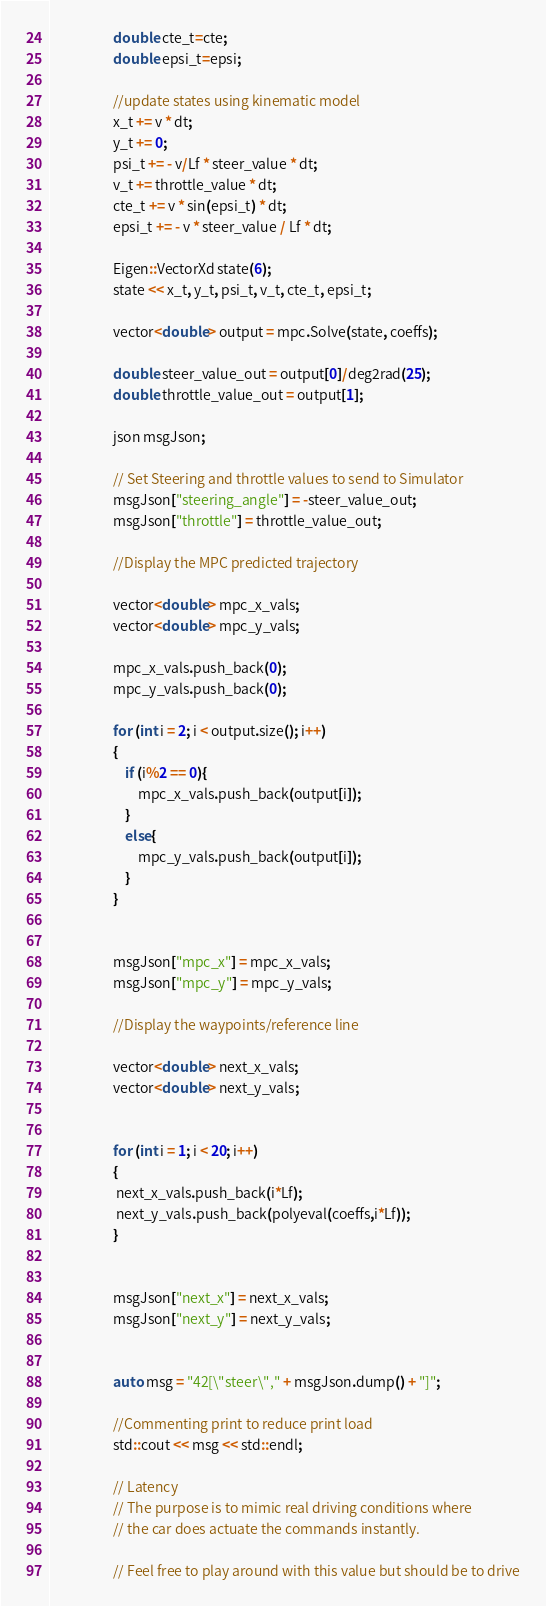Convert code to text. <code><loc_0><loc_0><loc_500><loc_500><_C++_>				    double cte_t=cte;
				    double epsi_t=epsi;

				    //update states using kinematic model
				    x_t += v * dt;
				    y_t += 0;
				    psi_t += - v/Lf * steer_value * dt;
				    v_t += throttle_value * dt;
				    cte_t += v * sin(epsi_t) * dt;
				    epsi_t += - v * steer_value / Lf * dt;

					Eigen::VectorXd state(6);
					state << x_t, y_t, psi_t, v_t, cte_t, epsi_t;

					vector<double> output = mpc.Solve(state, coeffs);

					double steer_value_out = output[0]/deg2rad(25);
					double throttle_value_out = output[1];

					json msgJson;

					// Set Steering and throttle values to send to Simulator
					msgJson["steering_angle"] = -steer_value_out;
					msgJson["throttle"] = throttle_value_out;

					//Display the MPC predicted trajectory

					vector<double> mpc_x_vals;
					vector<double> mpc_y_vals;

					mpc_x_vals.push_back(0);
				    mpc_y_vals.push_back(0);

				    for (int i = 2; i < output.size(); i++)
				    {
				    	if (i%2 == 0){
				    		mpc_x_vals.push_back(output[i]);
				    	}
				    	else{
				    		mpc_y_vals.push_back(output[i]);
				    	}
					}


					msgJson["mpc_x"] = mpc_x_vals;
					msgJson["mpc_y"] = mpc_y_vals;

					//Display the waypoints/reference line

					vector<double> next_x_vals;
					vector<double> next_y_vals;


				    for (int i = 1; i < 20; i++)
				    {
					 next_x_vals.push_back(i*Lf);
					 next_y_vals.push_back(polyeval(coeffs,i*Lf));
		            }


					msgJson["next_x"] = next_x_vals;
					msgJson["next_y"] = next_y_vals;


					auto msg = "42[\"steer\"," + msgJson.dump() + "]";

					//Commenting print to reduce print load
					std::cout << msg << std::endl;

					// Latency
					// The purpose is to mimic real driving conditions where
					// the car does actuate the commands instantly.

					// Feel free to play around with this value but should be to drive</code> 